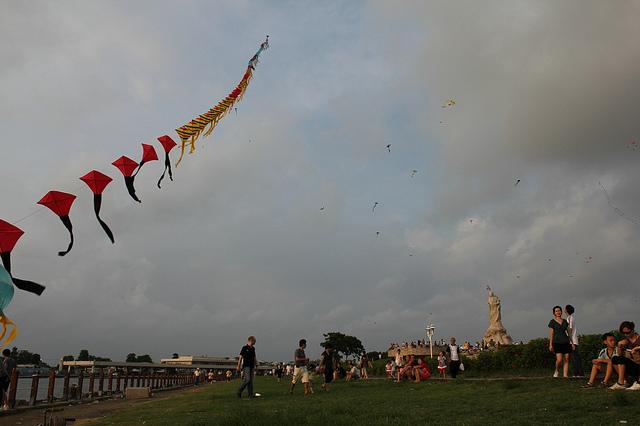What color are the first 6 kites?
Be succinct. Red. Is that a dragon made of kites?
Quick response, please. Yes. How many children are in this scene?
Quick response, please. Many. 